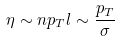<formula> <loc_0><loc_0><loc_500><loc_500>\eta \sim n p _ { T } l \sim \frac { p _ { T } } { \sigma }</formula> 